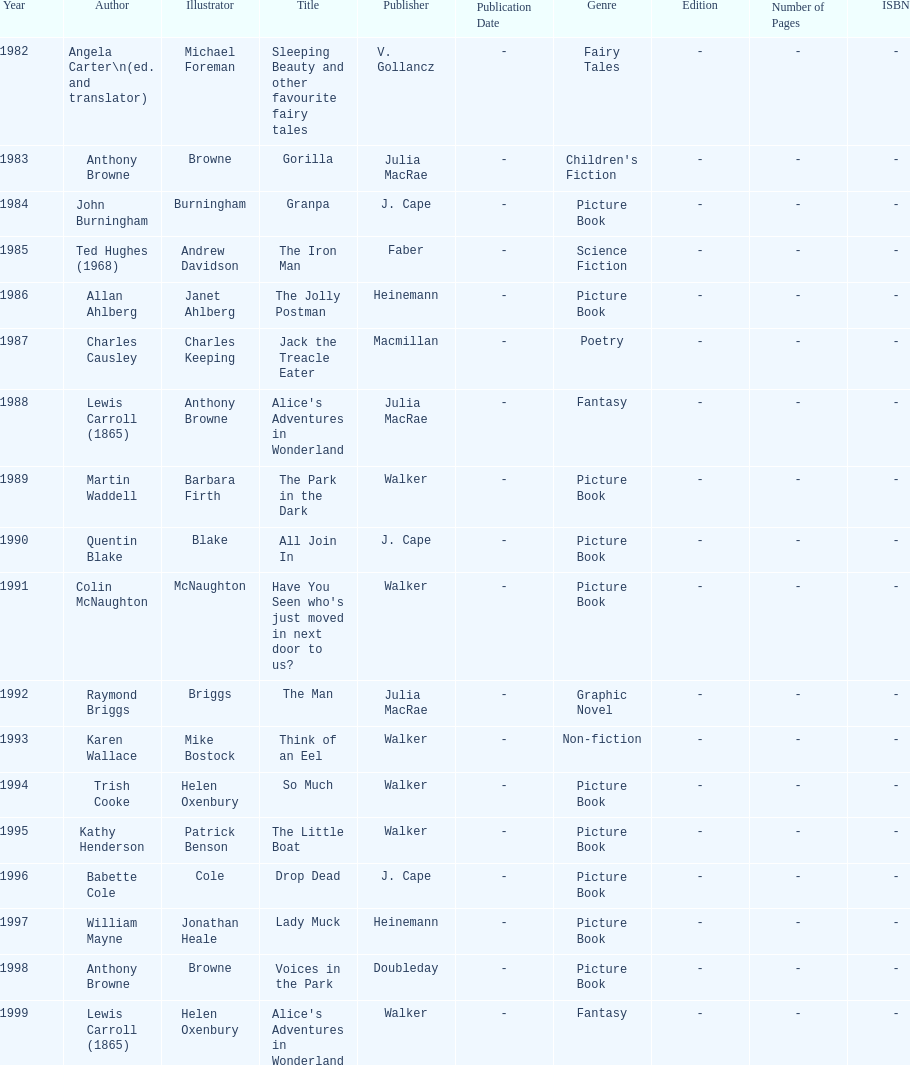Which other author, besides lewis carroll, has won the kurt maschler award twice? Anthony Browne. 